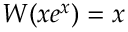Convert formula to latex. <formula><loc_0><loc_0><loc_500><loc_500>W ( x e ^ { x } ) = x</formula> 